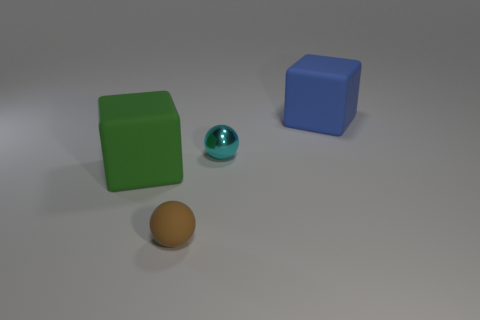Is the cyan thing made of the same material as the brown ball?
Offer a terse response. No. Are there any blue cubes of the same size as the cyan shiny ball?
Provide a short and direct response. No. There is a brown thing that is the same size as the cyan object; what is it made of?
Provide a succinct answer. Rubber. Are there any other big green matte things that have the same shape as the green object?
Keep it short and to the point. No. There is a big thing in front of the big blue rubber thing; what shape is it?
Your answer should be compact. Cube. What number of purple rubber cylinders are there?
Provide a succinct answer. 0. There is a ball that is the same material as the big blue thing; what color is it?
Your response must be concise. Brown. How many tiny objects are either brown matte objects or rubber objects?
Offer a terse response. 1. What number of spheres are behind the brown sphere?
Provide a succinct answer. 1. What is the color of the tiny rubber thing that is the same shape as the cyan metal object?
Provide a short and direct response. Brown. 